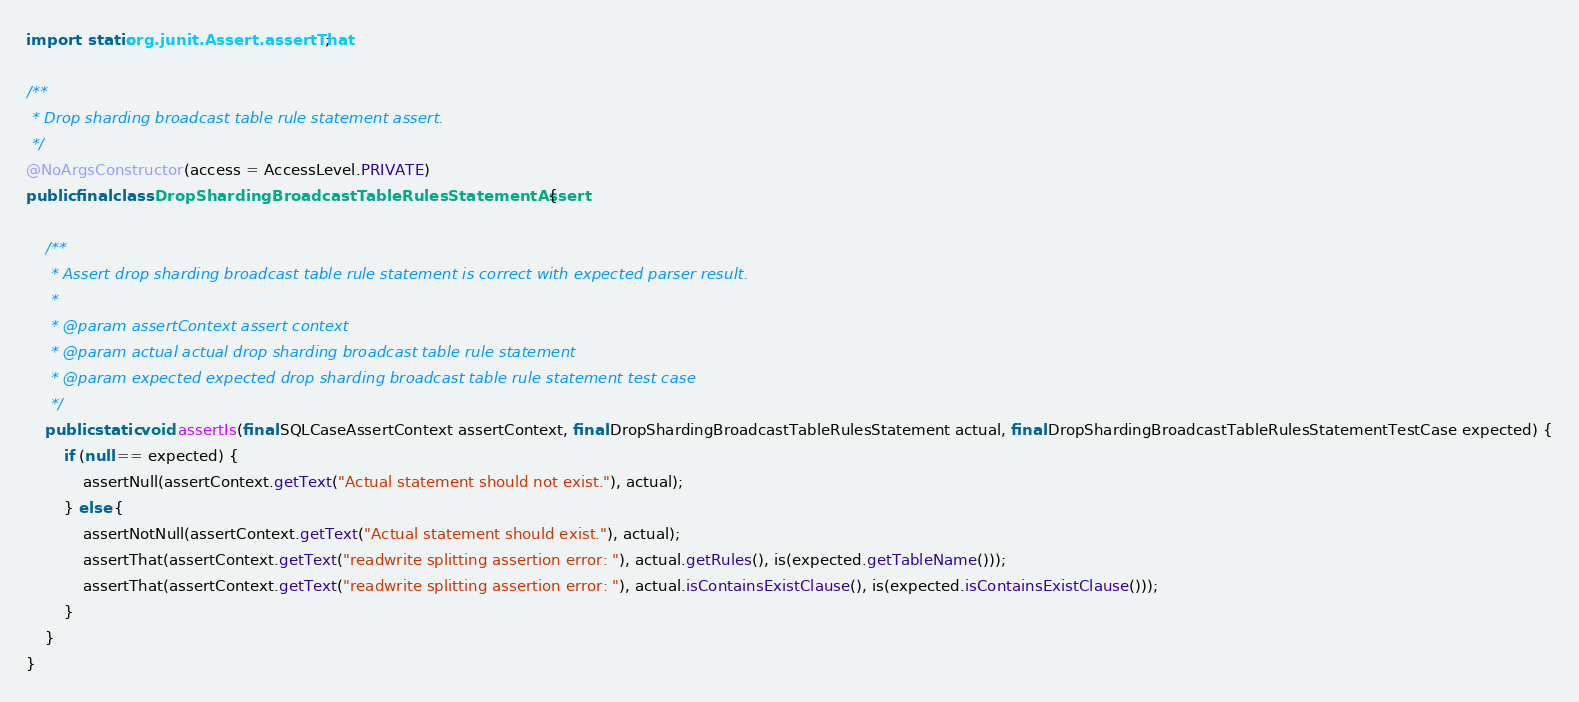Convert code to text. <code><loc_0><loc_0><loc_500><loc_500><_Java_>import static org.junit.Assert.assertThat;

/**
 * Drop sharding broadcast table rule statement assert.
 */
@NoArgsConstructor(access = AccessLevel.PRIVATE)
public final class DropShardingBroadcastTableRulesStatementAssert {
    
    /**
     * Assert drop sharding broadcast table rule statement is correct with expected parser result.
     *
     * @param assertContext assert context
     * @param actual actual drop sharding broadcast table rule statement
     * @param expected expected drop sharding broadcast table rule statement test case
     */
    public static void assertIs(final SQLCaseAssertContext assertContext, final DropShardingBroadcastTableRulesStatement actual, final DropShardingBroadcastTableRulesStatementTestCase expected) {
        if (null == expected) {
            assertNull(assertContext.getText("Actual statement should not exist."), actual);
        } else {
            assertNotNull(assertContext.getText("Actual statement should exist."), actual);
            assertThat(assertContext.getText("readwrite splitting assertion error: "), actual.getRules(), is(expected.getTableName()));
            assertThat(assertContext.getText("readwrite splitting assertion error: "), actual.isContainsExistClause(), is(expected.isContainsExistClause()));
        }
    }
}
</code> 